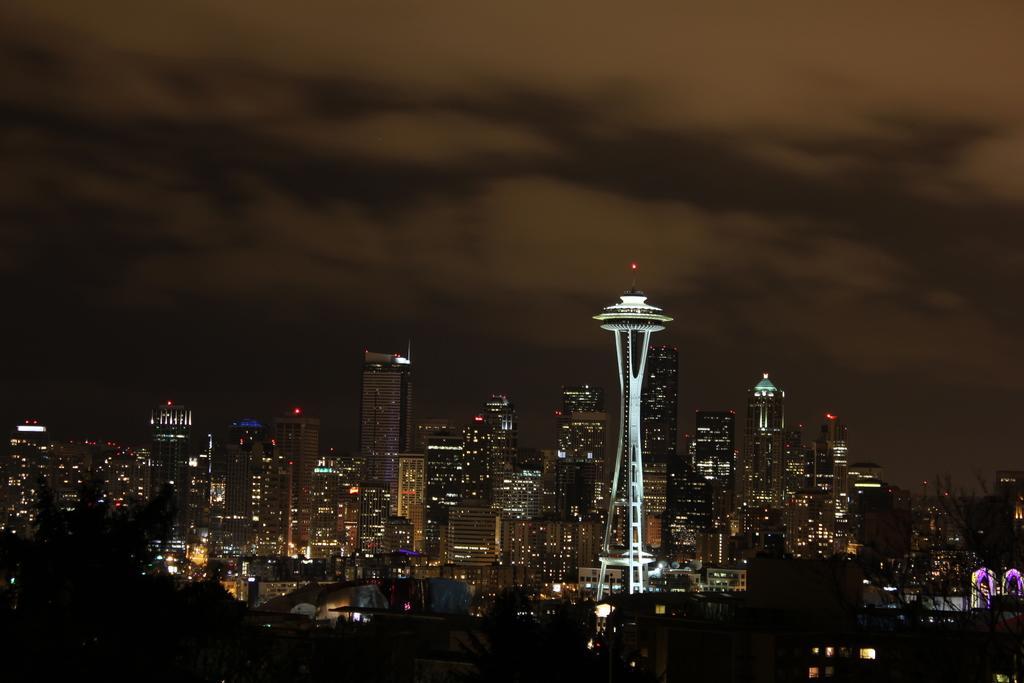Describe this image in one or two sentences. This image consists of many buildings and skyscrapers. In the background, we can see the clouds in the sky. 